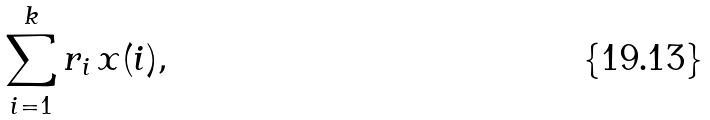Convert formula to latex. <formula><loc_0><loc_0><loc_500><loc_500>\sum _ { i = 1 } ^ { k } r _ { i } \, x ( i ) ,</formula> 